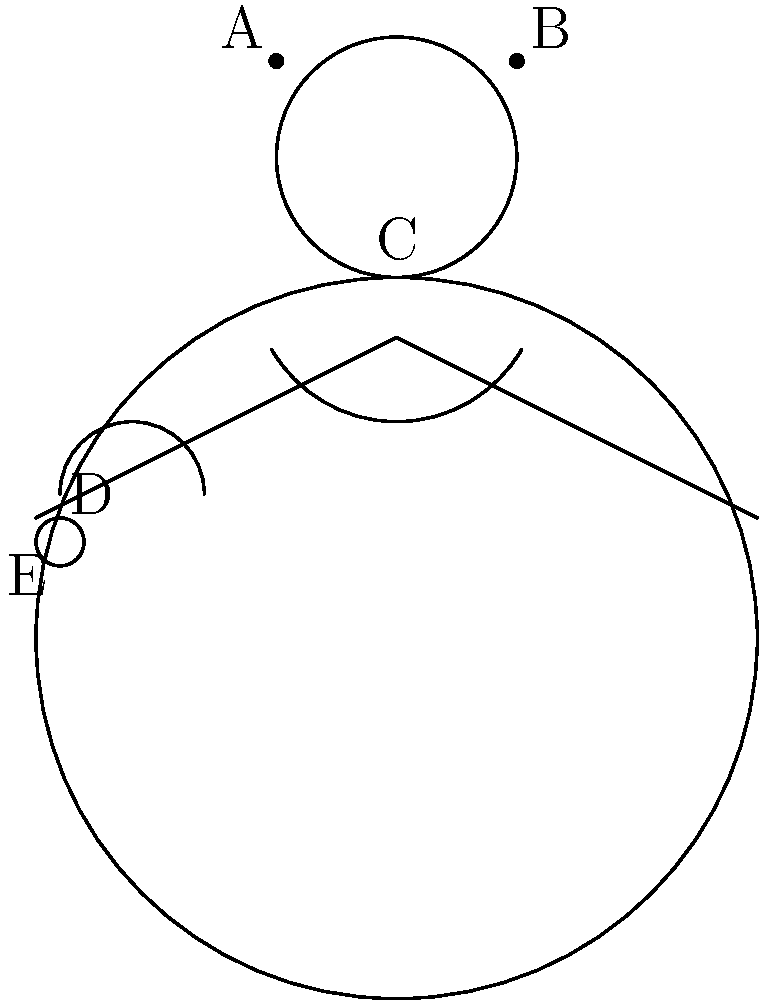As a style advisor, which combination of accessories would you recommend for a formal evening event to create a balanced and elegant look? Select the best option using the labels provided in the image. To answer this question, we need to consider the principles of formal evening wear and balanced accessorizing:

1. Formal evening events typically call for elegant, sophisticated accessories.

2. A balanced look avoids over-accessorizing while still creating a cohesive appearance.

3. Let's analyze each accessory:
   A and B: Earrings - add sparkle and frame the face
   C: Necklace - draws attention to the neckline and adds elegance
   D: Bracelet - adds interest to the wrist area
   E: Ring - a subtle detail that complements other jewelry

4. For a formal evening look, we want to create a focal point without overwhelming the outfit.

5. The necklace (C) is often the centerpiece for formal wear, so we should include it.

6. Earrings (A and B) complement the necklace and balance the look around the face.

7. To avoid over-accessorizing, we should choose either the bracelet (D) or the ring (E), but not both.

8. The bracelet (D) is more noticeable and adds more impact to the overall look compared to the ring.

Therefore, the best combination for a balanced and elegant formal evening look would be the earrings (A and B), necklace (C), and bracelet (D).
Answer: A, B, C, D 